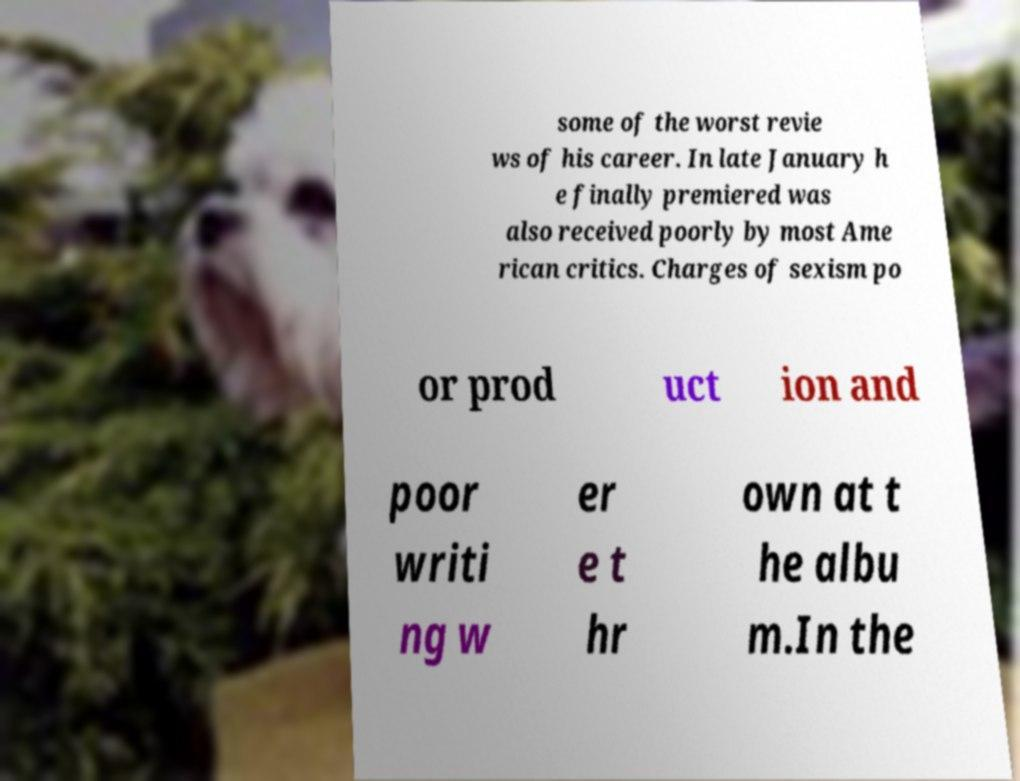Please read and relay the text visible in this image. What does it say? some of the worst revie ws of his career. In late January h e finally premiered was also received poorly by most Ame rican critics. Charges of sexism po or prod uct ion and poor writi ng w er e t hr own at t he albu m.In the 